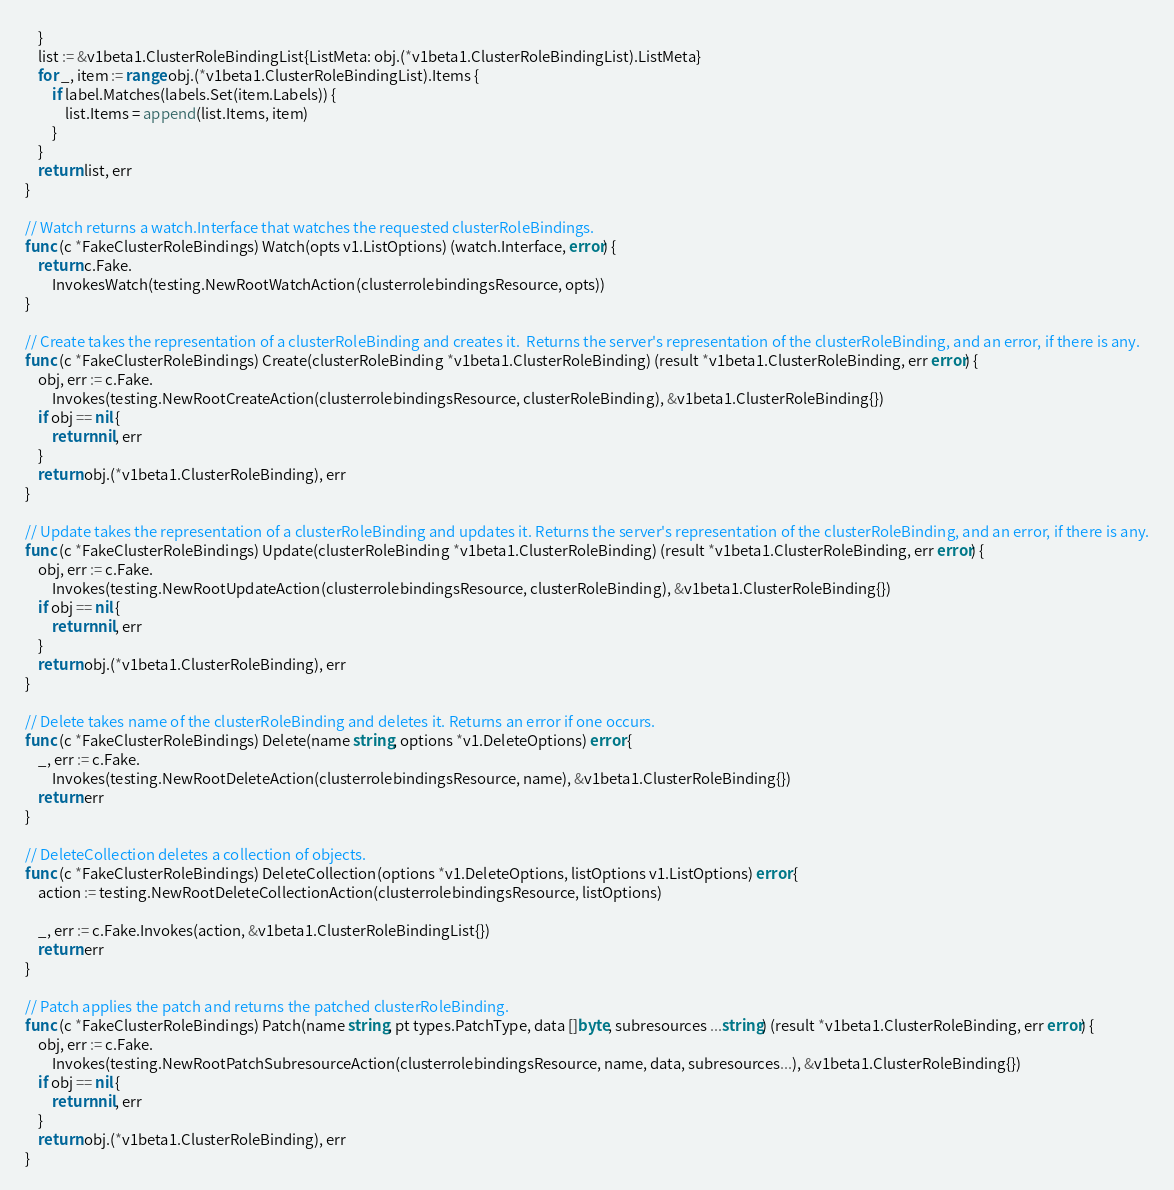<code> <loc_0><loc_0><loc_500><loc_500><_Go_>	}
	list := &v1beta1.ClusterRoleBindingList{ListMeta: obj.(*v1beta1.ClusterRoleBindingList).ListMeta}
	for _, item := range obj.(*v1beta1.ClusterRoleBindingList).Items {
		if label.Matches(labels.Set(item.Labels)) {
			list.Items = append(list.Items, item)
		}
	}
	return list, err
}

// Watch returns a watch.Interface that watches the requested clusterRoleBindings.
func (c *FakeClusterRoleBindings) Watch(opts v1.ListOptions) (watch.Interface, error) {
	return c.Fake.
		InvokesWatch(testing.NewRootWatchAction(clusterrolebindingsResource, opts))
}

// Create takes the representation of a clusterRoleBinding and creates it.  Returns the server's representation of the clusterRoleBinding, and an error, if there is any.
func (c *FakeClusterRoleBindings) Create(clusterRoleBinding *v1beta1.ClusterRoleBinding) (result *v1beta1.ClusterRoleBinding, err error) {
	obj, err := c.Fake.
		Invokes(testing.NewRootCreateAction(clusterrolebindingsResource, clusterRoleBinding), &v1beta1.ClusterRoleBinding{})
	if obj == nil {
		return nil, err
	}
	return obj.(*v1beta1.ClusterRoleBinding), err
}

// Update takes the representation of a clusterRoleBinding and updates it. Returns the server's representation of the clusterRoleBinding, and an error, if there is any.
func (c *FakeClusterRoleBindings) Update(clusterRoleBinding *v1beta1.ClusterRoleBinding) (result *v1beta1.ClusterRoleBinding, err error) {
	obj, err := c.Fake.
		Invokes(testing.NewRootUpdateAction(clusterrolebindingsResource, clusterRoleBinding), &v1beta1.ClusterRoleBinding{})
	if obj == nil {
		return nil, err
	}
	return obj.(*v1beta1.ClusterRoleBinding), err
}

// Delete takes name of the clusterRoleBinding and deletes it. Returns an error if one occurs.
func (c *FakeClusterRoleBindings) Delete(name string, options *v1.DeleteOptions) error {
	_, err := c.Fake.
		Invokes(testing.NewRootDeleteAction(clusterrolebindingsResource, name), &v1beta1.ClusterRoleBinding{})
	return err
}

// DeleteCollection deletes a collection of objects.
func (c *FakeClusterRoleBindings) DeleteCollection(options *v1.DeleteOptions, listOptions v1.ListOptions) error {
	action := testing.NewRootDeleteCollectionAction(clusterrolebindingsResource, listOptions)

	_, err := c.Fake.Invokes(action, &v1beta1.ClusterRoleBindingList{})
	return err
}

// Patch applies the patch and returns the patched clusterRoleBinding.
func (c *FakeClusterRoleBindings) Patch(name string, pt types.PatchType, data []byte, subresources ...string) (result *v1beta1.ClusterRoleBinding, err error) {
	obj, err := c.Fake.
		Invokes(testing.NewRootPatchSubresourceAction(clusterrolebindingsResource, name, data, subresources...), &v1beta1.ClusterRoleBinding{})
	if obj == nil {
		return nil, err
	}
	return obj.(*v1beta1.ClusterRoleBinding), err
}
</code> 